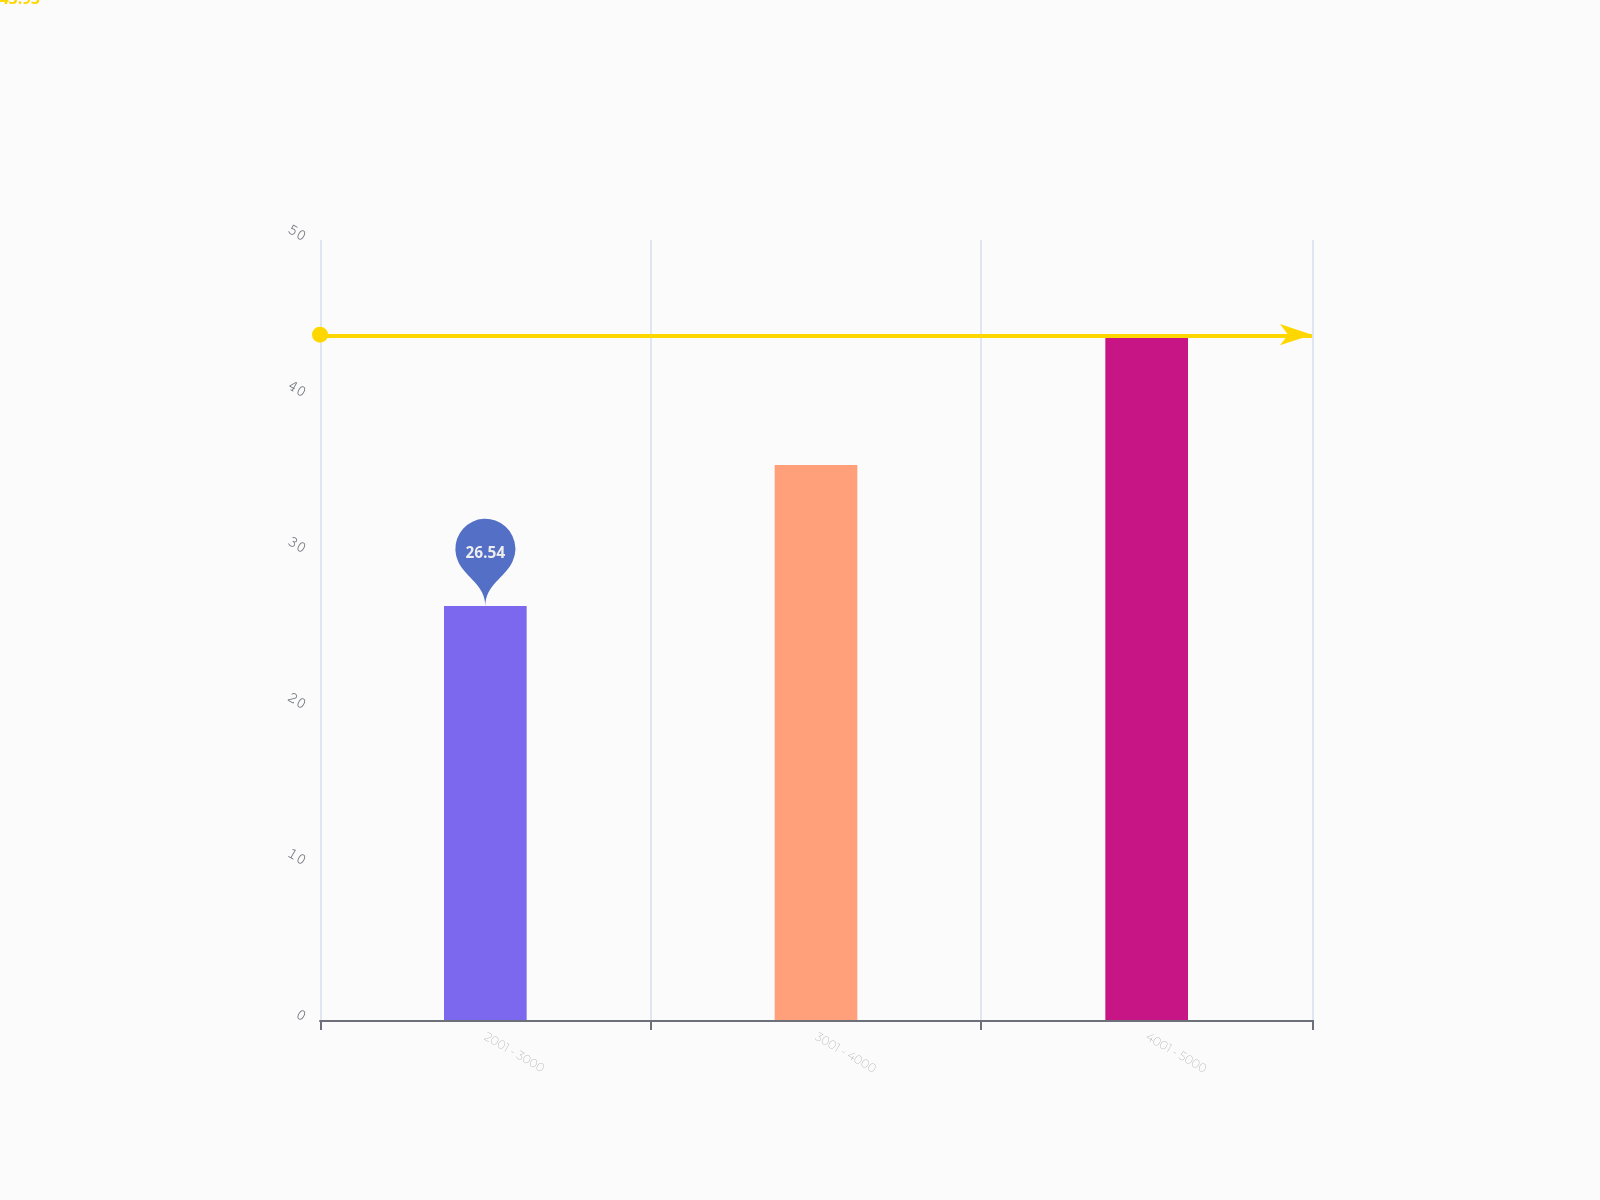Convert chart. <chart><loc_0><loc_0><loc_500><loc_500><bar_chart><fcel>2001 - 3000<fcel>3001 - 4000<fcel>4001 - 5000<nl><fcel>26.54<fcel>35.57<fcel>43.93<nl></chart> 